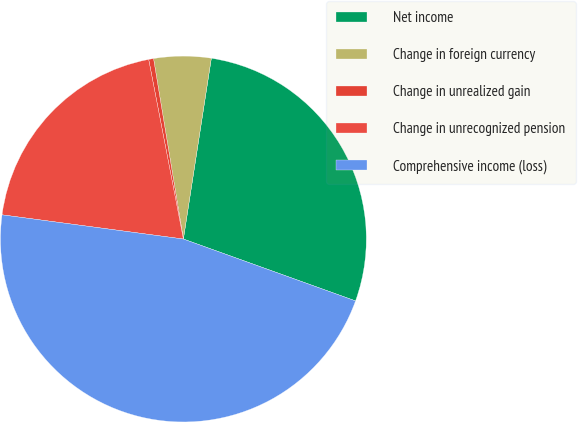Convert chart. <chart><loc_0><loc_0><loc_500><loc_500><pie_chart><fcel>Net income<fcel>Change in foreign currency<fcel>Change in unrealized gain<fcel>Change in unrecognized pension<fcel>Comprehensive income (loss)<nl><fcel>28.05%<fcel>5.05%<fcel>0.43%<fcel>19.85%<fcel>46.62%<nl></chart> 